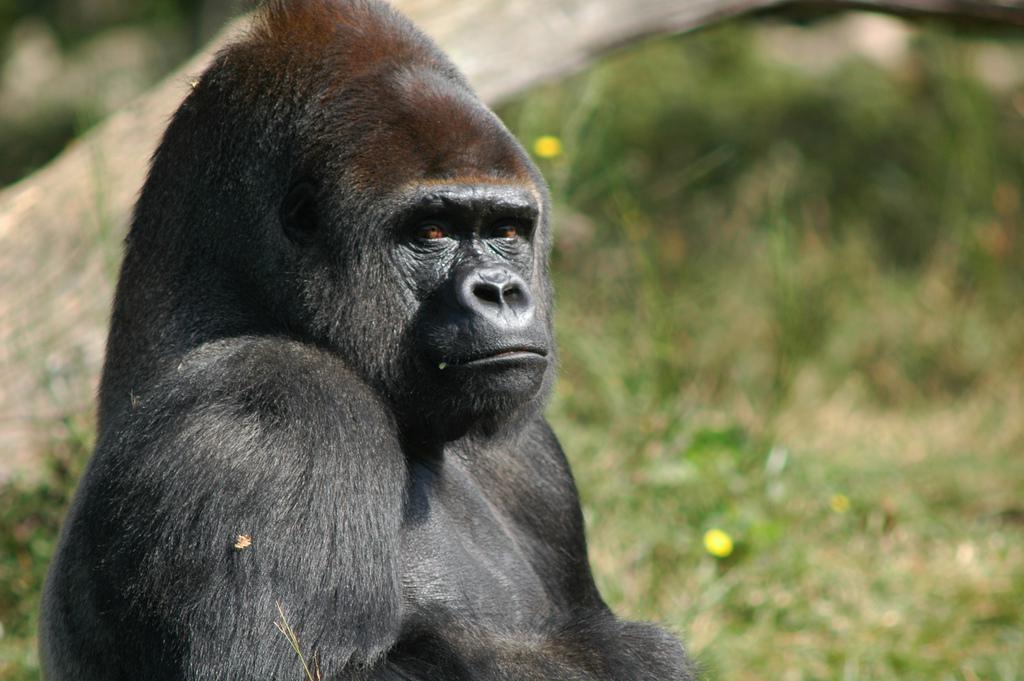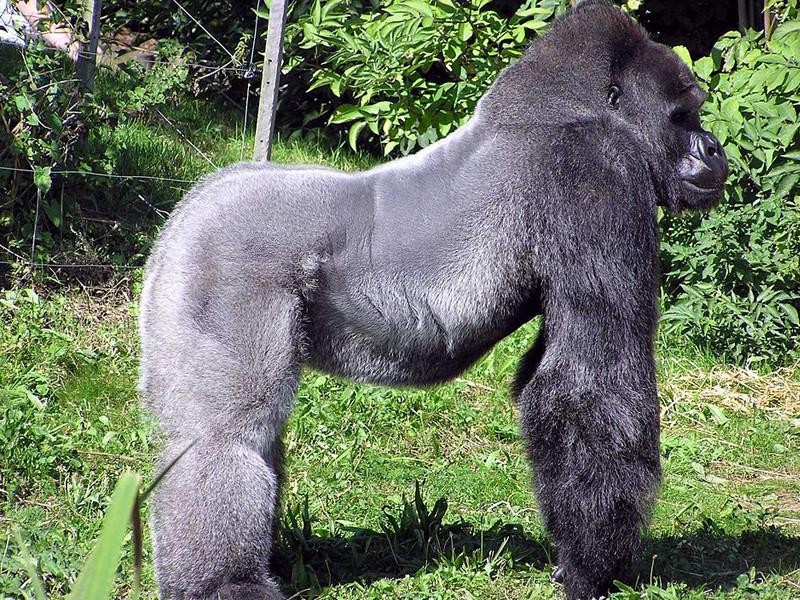The first image is the image on the left, the second image is the image on the right. For the images displayed, is the sentence "In the image to the right, a gorilla stands on all fours." factually correct? Answer yes or no. Yes. The first image is the image on the left, the second image is the image on the right. Given the left and right images, does the statement "In the right image, there's a silverback gorilla standing on all fours." hold true? Answer yes or no. Yes. 